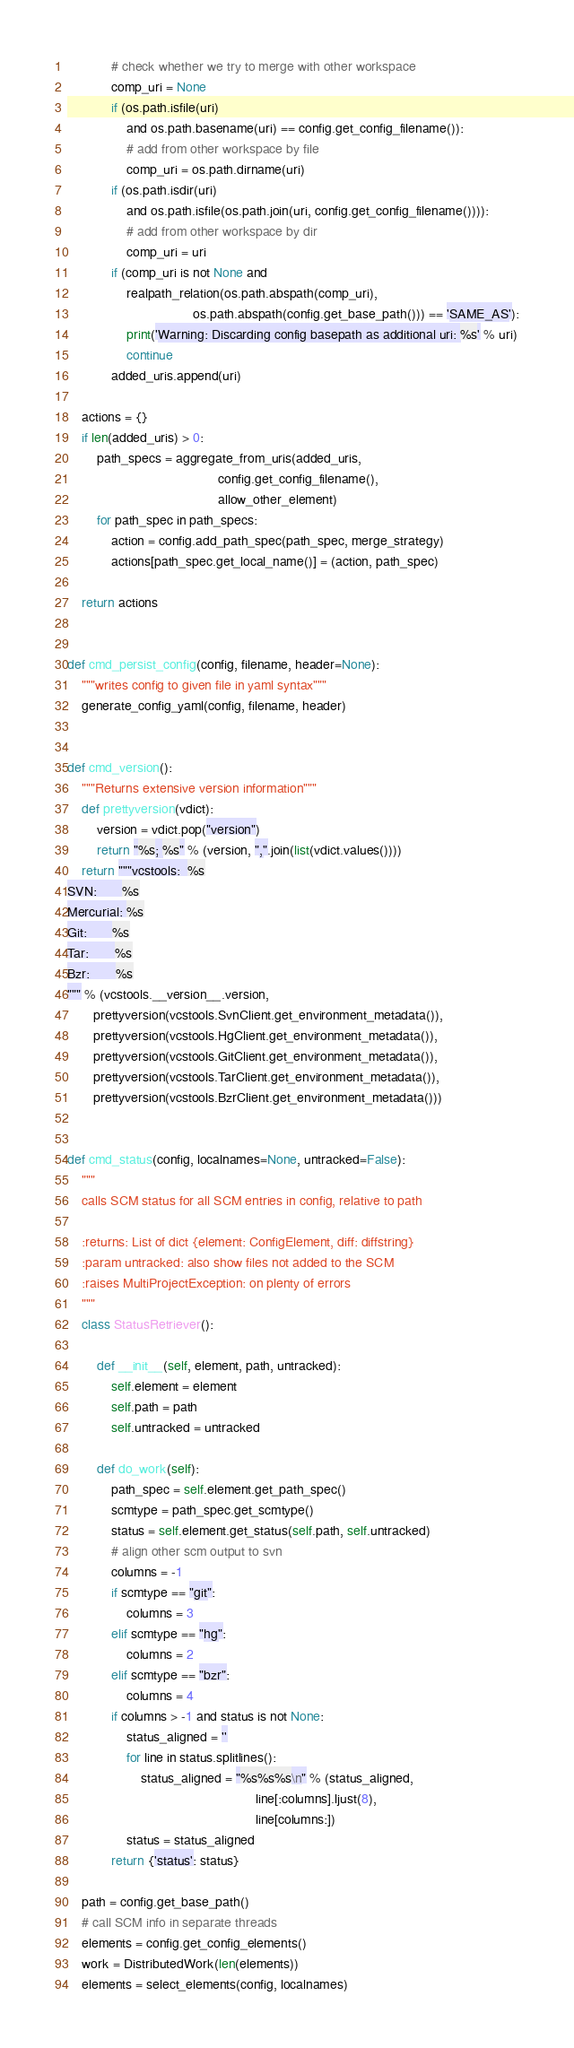<code> <loc_0><loc_0><loc_500><loc_500><_Python_>            # check whether we try to merge with other workspace
            comp_uri = None
            if (os.path.isfile(uri)
                and os.path.basename(uri) == config.get_config_filename()):
                # add from other workspace by file
                comp_uri = os.path.dirname(uri)
            if (os.path.isdir(uri)
                and os.path.isfile(os.path.join(uri, config.get_config_filename()))):
                # add from other workspace by dir
                comp_uri = uri
            if (comp_uri is not None and
                realpath_relation(os.path.abspath(comp_uri),
                                  os.path.abspath(config.get_base_path())) == 'SAME_AS'):
                print('Warning: Discarding config basepath as additional uri: %s' % uri)
                continue
            added_uris.append(uri)

    actions = {}
    if len(added_uris) > 0:
        path_specs = aggregate_from_uris(added_uris,
                                         config.get_config_filename(),
                                         allow_other_element)
        for path_spec in path_specs:
            action = config.add_path_spec(path_spec, merge_strategy)
            actions[path_spec.get_local_name()] = (action, path_spec)

    return actions


def cmd_persist_config(config, filename, header=None):
    """writes config to given file in yaml syntax"""
    generate_config_yaml(config, filename, header)


def cmd_version():
    """Returns extensive version information"""
    def prettyversion(vdict):
        version = vdict.pop("version")
        return "%s; %s" % (version, ",".join(list(vdict.values())))
    return """vcstools:  %s
SVN:       %s
Mercurial: %s
Git:       %s
Tar:       %s
Bzr:       %s
""" % (vcstools.__version__.version,
       prettyversion(vcstools.SvnClient.get_environment_metadata()),
       prettyversion(vcstools.HgClient.get_environment_metadata()),
       prettyversion(vcstools.GitClient.get_environment_metadata()),
       prettyversion(vcstools.TarClient.get_environment_metadata()),
       prettyversion(vcstools.BzrClient.get_environment_metadata()))


def cmd_status(config, localnames=None, untracked=False):
    """
    calls SCM status for all SCM entries in config, relative to path

    :returns: List of dict {element: ConfigElement, diff: diffstring}
    :param untracked: also show files not added to the SCM
    :raises MultiProjectException: on plenty of errors
    """
    class StatusRetriever():

        def __init__(self, element, path, untracked):
            self.element = element
            self.path = path
            self.untracked = untracked

        def do_work(self):
            path_spec = self.element.get_path_spec()
            scmtype = path_spec.get_scmtype()
            status = self.element.get_status(self.path, self.untracked)
            # align other scm output to svn
            columns = -1
            if scmtype == "git":
                columns = 3
            elif scmtype == "hg":
                columns = 2
            elif scmtype == "bzr":
                columns = 4
            if columns > -1 and status is not None:
                status_aligned = ''
                for line in status.splitlines():
                    status_aligned = "%s%s%s\n" % (status_aligned,
                                                   line[:columns].ljust(8),
                                                   line[columns:])
                status = status_aligned
            return {'status': status}

    path = config.get_base_path()
    # call SCM info in separate threads
    elements = config.get_config_elements()
    work = DistributedWork(len(elements))
    elements = select_elements(config, localnames)</code> 